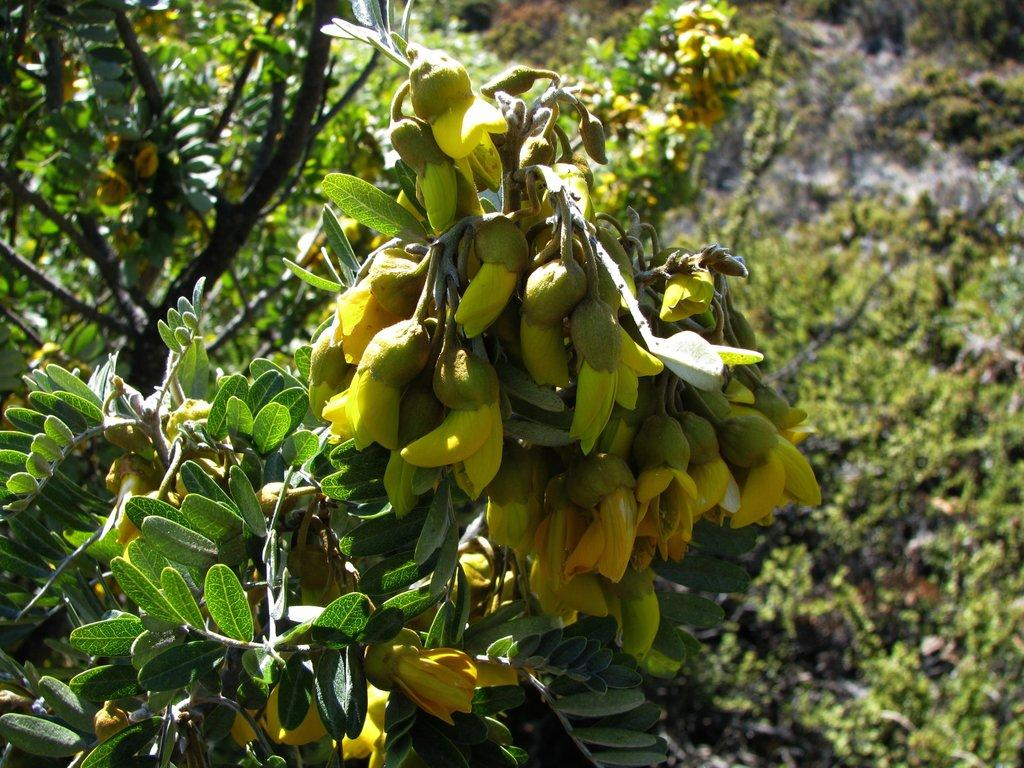What type of vegetation can be seen in the image? There are trees, flowers, and leaves in the image. Can you describe the colors of the flowers in the image? The colors of the flowers in the image cannot be determined from the provided facts. What is the primary feature of the trees in the image? The primary feature of the trees in the image is their presence, but their specific characteristics cannot be determined from the provided facts. How many goldfish can be seen swimming in the image? There are no goldfish present in the image; it features trees, flowers, and leaves. What type of stone is used to create the form of the trees in the image? There is no information about the type of stone or the form of the trees in the image. 